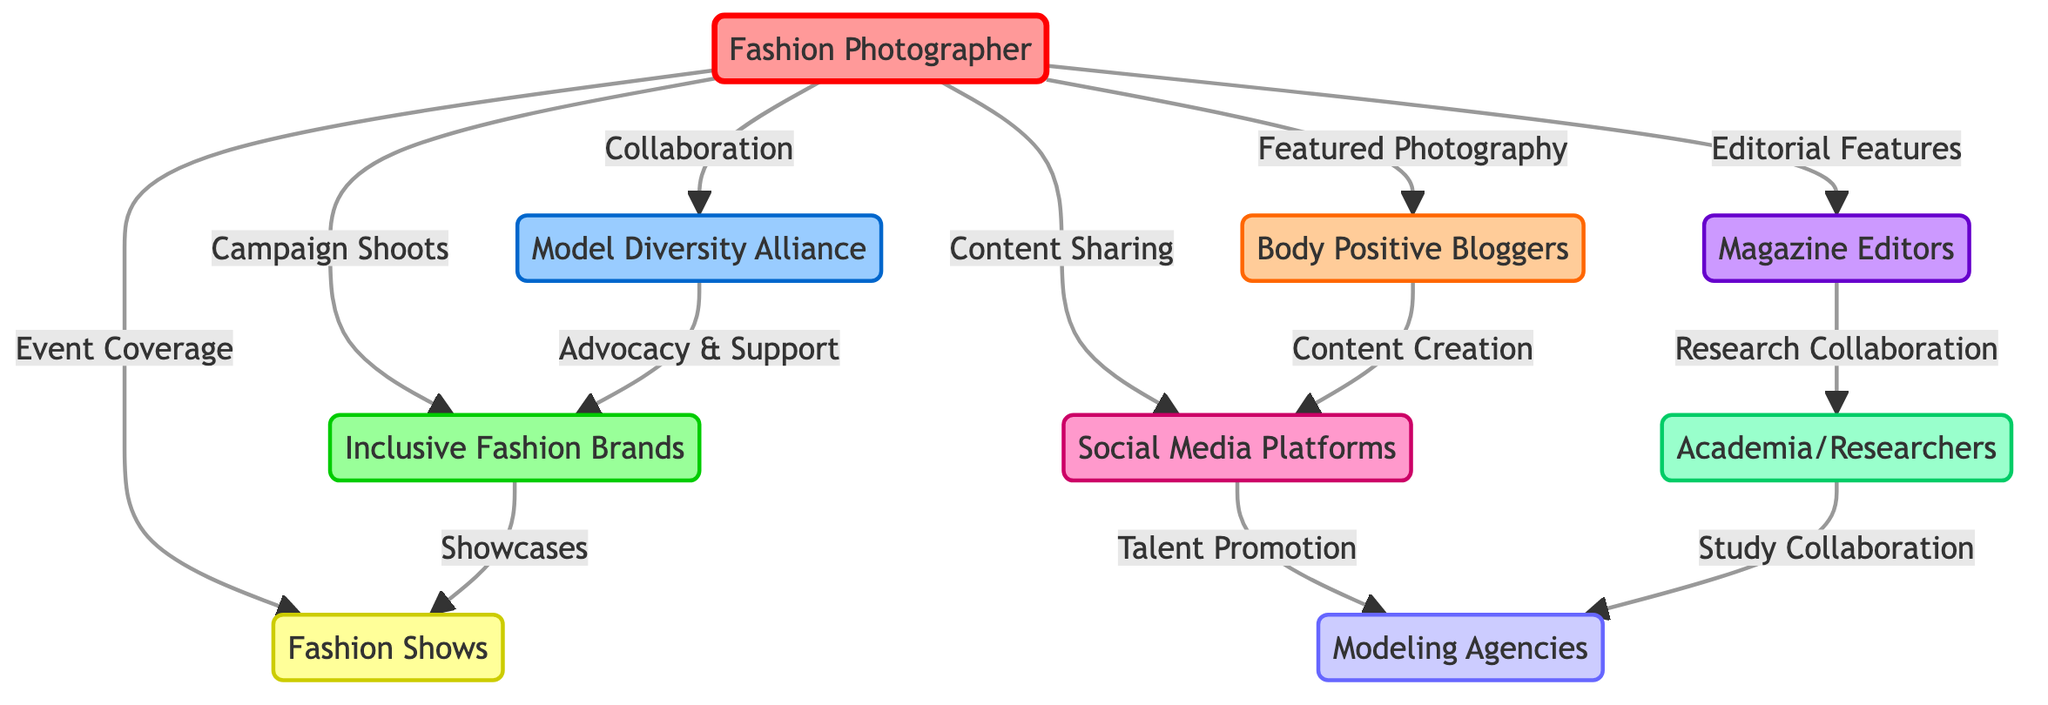What is the total number of nodes in the diagram? The nodes in the diagram are the entities represented by circles or points. By counting the nodes listed in the data section, we see there are nine: You, Model Diversity Alliance, Body Positive Bloggers, Inclusive Fashion Brands, Magazine Editors, Fashion Shows, Social Media Platforms, Academia/Researchers, and Modeling Agencies.
Answer: 9 What type of relationship does the Fashion Photographer have with the Model Diversity Alliance? The relationship shown from "You" (Fashion Photographer) to "Model Diversity Alliance" is labeled "Collaboration". This indicates that the Fashion Photographer collaborates with the Model Diversity Alliance.
Answer: Collaboration Which entity is connected to the Body Positive Bloggers through content creation? From the diagram, the Body Positive Bloggers are connected to the Social Media Platforms with the label "Content Creation". This shows that Body Positive Bloggers engage in content creation on Social Media Platforms.
Answer: Social Media Platforms How many connections does the Inclusive Fashion Brands have in the diagram? Counting the edges (connections) related to Inclusive Fashion Brands, we find three: one to the Fashion Photographer for "Campaign Shoots", one to the Model Diversity Alliance for "Advocacy & Support", and one to Fashion Shows for "Showcases". Therefore, Inclusive Fashion Brands has three connections.
Answer: 3 Who collaborates with Magazine Editors in research? The edge directed from Magazine Editors to Academia/Researchers is labeled "Research Collaboration", indicating that Magazine Editors work together with Academia/Researchers in research endeavors.
Answer: Academia/Researchers Which node has the most connections? By reviewing the edges in the diagram, we see that the Fashion Photographer has six connections (to Model Diversity Alliance, Body Positive Bloggers, Inclusive Fashion Brands, Magazine Editors, Fashion Shows, and Social Media Platforms). Thus, the Fashion Photographer has the most connections.
Answer: Fashion Photographer Which two nodes are connected through advocacy and support? The connection represented from Model Diversity Alliance to Inclusive Fashion Brands is labeled "Advocacy & Support", indicating that these two nodes are interconnected through advocacy efforts.
Answer: Inclusive Fashion Brands What is the relationship between Social Media Platforms and Modeling Agencies? The relationship is labeled "Talent Promotion", which shows that Social Media Platforms promote talent associated with Modeling Agencies, indicating a supportive role by Social Media Platforms regarding talent.
Answer: Talent Promotion Which node connects to the Fashion Shows through showcases? The Inclusive Fashion Brands connect to the Fashion Shows with the label "Showcases", indicating how they showcase fashion within these shows.
Answer: Inclusive Fashion Brands 